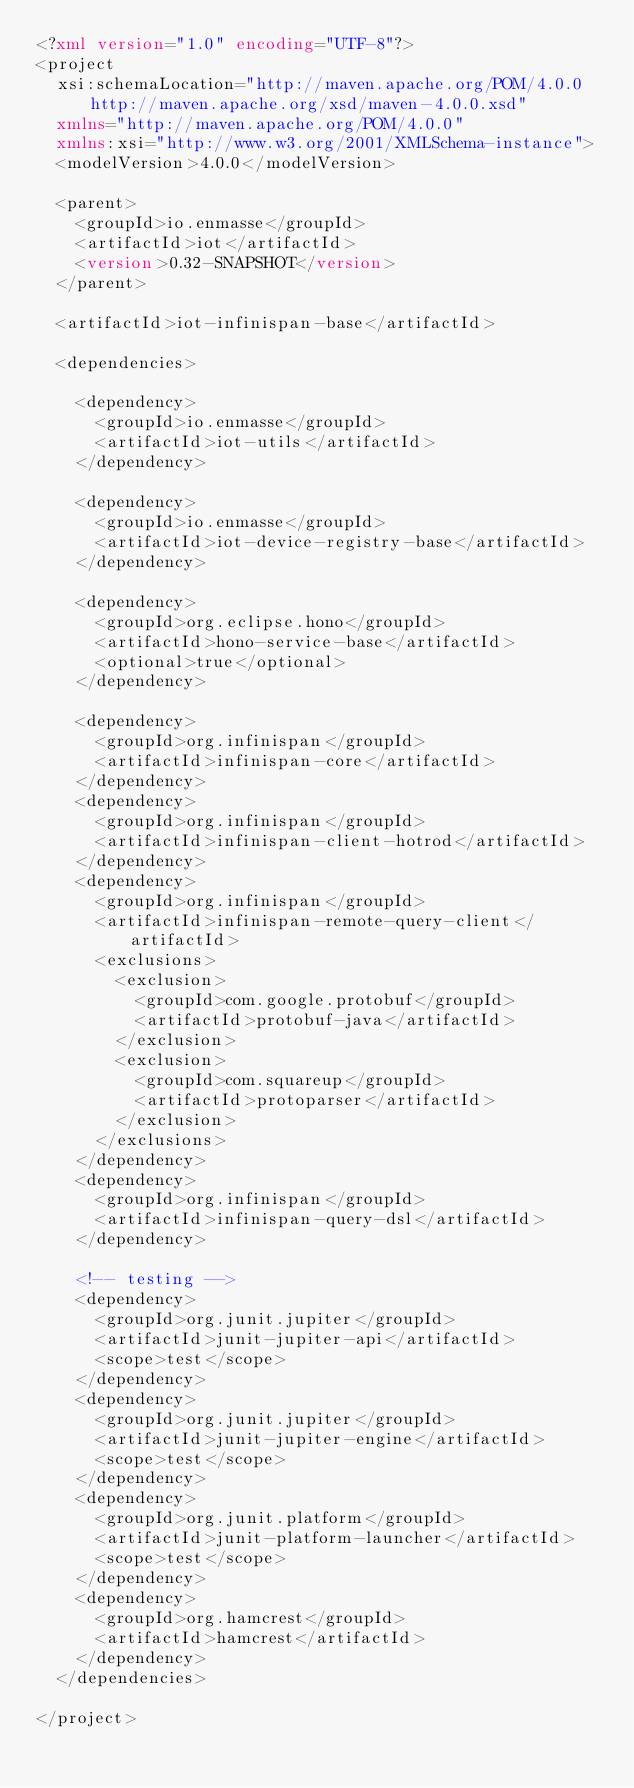Convert code to text. <code><loc_0><loc_0><loc_500><loc_500><_XML_><?xml version="1.0" encoding="UTF-8"?>
<project
  xsi:schemaLocation="http://maven.apache.org/POM/4.0.0 http://maven.apache.org/xsd/maven-4.0.0.xsd"
  xmlns="http://maven.apache.org/POM/4.0.0"
  xmlns:xsi="http://www.w3.org/2001/XMLSchema-instance">
  <modelVersion>4.0.0</modelVersion>

  <parent>
    <groupId>io.enmasse</groupId>
    <artifactId>iot</artifactId>
    <version>0.32-SNAPSHOT</version>
  </parent>

  <artifactId>iot-infinispan-base</artifactId>

  <dependencies>

    <dependency>
      <groupId>io.enmasse</groupId>
      <artifactId>iot-utils</artifactId>
    </dependency>

    <dependency>
      <groupId>io.enmasse</groupId>
      <artifactId>iot-device-registry-base</artifactId>
    </dependency>

    <dependency>
      <groupId>org.eclipse.hono</groupId>
      <artifactId>hono-service-base</artifactId>
      <optional>true</optional>
    </dependency>

    <dependency>
      <groupId>org.infinispan</groupId>
      <artifactId>infinispan-core</artifactId>
    </dependency>
    <dependency>
      <groupId>org.infinispan</groupId>
      <artifactId>infinispan-client-hotrod</artifactId>
    </dependency>
    <dependency>
      <groupId>org.infinispan</groupId>
      <artifactId>infinispan-remote-query-client</artifactId>
      <exclusions>
        <exclusion>
          <groupId>com.google.protobuf</groupId>
          <artifactId>protobuf-java</artifactId>
        </exclusion>
        <exclusion>
          <groupId>com.squareup</groupId>
          <artifactId>protoparser</artifactId>
        </exclusion>
      </exclusions>
    </dependency>
    <dependency>
      <groupId>org.infinispan</groupId>
      <artifactId>infinispan-query-dsl</artifactId>
    </dependency>

    <!-- testing -->
    <dependency>
      <groupId>org.junit.jupiter</groupId>
      <artifactId>junit-jupiter-api</artifactId>
      <scope>test</scope>
    </dependency>
    <dependency>
      <groupId>org.junit.jupiter</groupId>
      <artifactId>junit-jupiter-engine</artifactId>
      <scope>test</scope>
    </dependency>
    <dependency>
      <groupId>org.junit.platform</groupId>
      <artifactId>junit-platform-launcher</artifactId>
      <scope>test</scope>
    </dependency>
    <dependency>
      <groupId>org.hamcrest</groupId>
      <artifactId>hamcrest</artifactId>
    </dependency>
  </dependencies>

</project>
</code> 